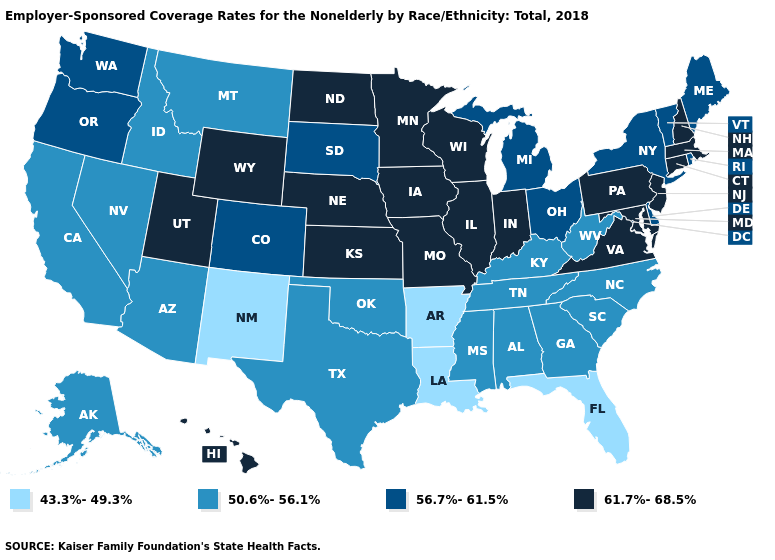Does Minnesota have the highest value in the MidWest?
Concise answer only. Yes. Name the states that have a value in the range 56.7%-61.5%?
Concise answer only. Colorado, Delaware, Maine, Michigan, New York, Ohio, Oregon, Rhode Island, South Dakota, Vermont, Washington. Name the states that have a value in the range 61.7%-68.5%?
Write a very short answer. Connecticut, Hawaii, Illinois, Indiana, Iowa, Kansas, Maryland, Massachusetts, Minnesota, Missouri, Nebraska, New Hampshire, New Jersey, North Dakota, Pennsylvania, Utah, Virginia, Wisconsin, Wyoming. What is the lowest value in the USA?
Concise answer only. 43.3%-49.3%. Among the states that border Indiana , does Kentucky have the lowest value?
Keep it brief. Yes. What is the lowest value in the South?
Keep it brief. 43.3%-49.3%. What is the value of Utah?
Keep it brief. 61.7%-68.5%. Among the states that border New Hampshire , which have the highest value?
Concise answer only. Massachusetts. Does Washington have a lower value than Colorado?
Short answer required. No. Does Rhode Island have a higher value than New Jersey?
Quick response, please. No. Does New York have a higher value than Kentucky?
Be succinct. Yes. Does Louisiana have the lowest value in the South?
Write a very short answer. Yes. What is the value of Nevada?
Answer briefly. 50.6%-56.1%. What is the value of Hawaii?
Give a very brief answer. 61.7%-68.5%. What is the highest value in states that border Illinois?
Answer briefly. 61.7%-68.5%. 